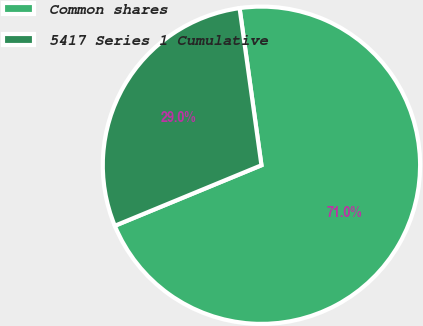Convert chart to OTSL. <chart><loc_0><loc_0><loc_500><loc_500><pie_chart><fcel>Common shares<fcel>5417 Series 1 Cumulative<nl><fcel>70.97%<fcel>29.03%<nl></chart> 